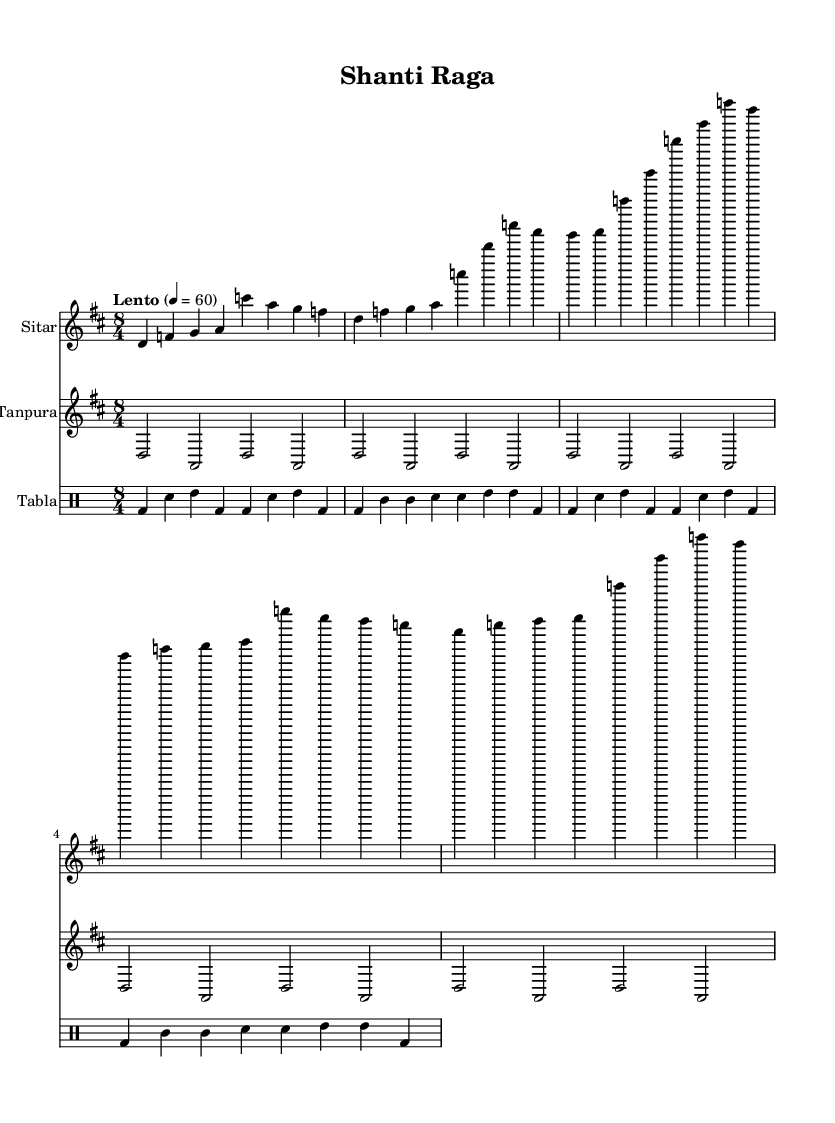What is the key signature of this music? The key signature is D major, indicated by two sharps (F# and C#).
Answer: D major What is the time signature of the piece? The time signature is 8/4, which means there are eight beats in a measure and the quarter note gets one beat.
Answer: 8/4 What is the tempo marking of this composition? The tempo marking "Lento" indicates a slow tempo, typically ranging around 40-60 beats per minute.
Answer: Lento Which instrument has a drone throughout the piece? The Tanpura is providing a continuous drone, characterized by its sustained notes.
Answer: Tanpura How many measures does the sitar part contain? By counting the distinct phrases and repetitions in the sitar section, we observe it comprises 5 measures.
Answer: 5 What rhythmic pattern is used for the tabla? The tabla features a simplified Teentaal rhythm, which is categorized by a sequence of ups and downs, generally denoting an intricate pattern in Indian music.
Answer: Teentaal What is the primary mood or function of this raga? The "Shanti Raga" is designed to evoke calmness and tranquility, making it ideal for meditation, especially after intense trauma cases.
Answer: Calmness 